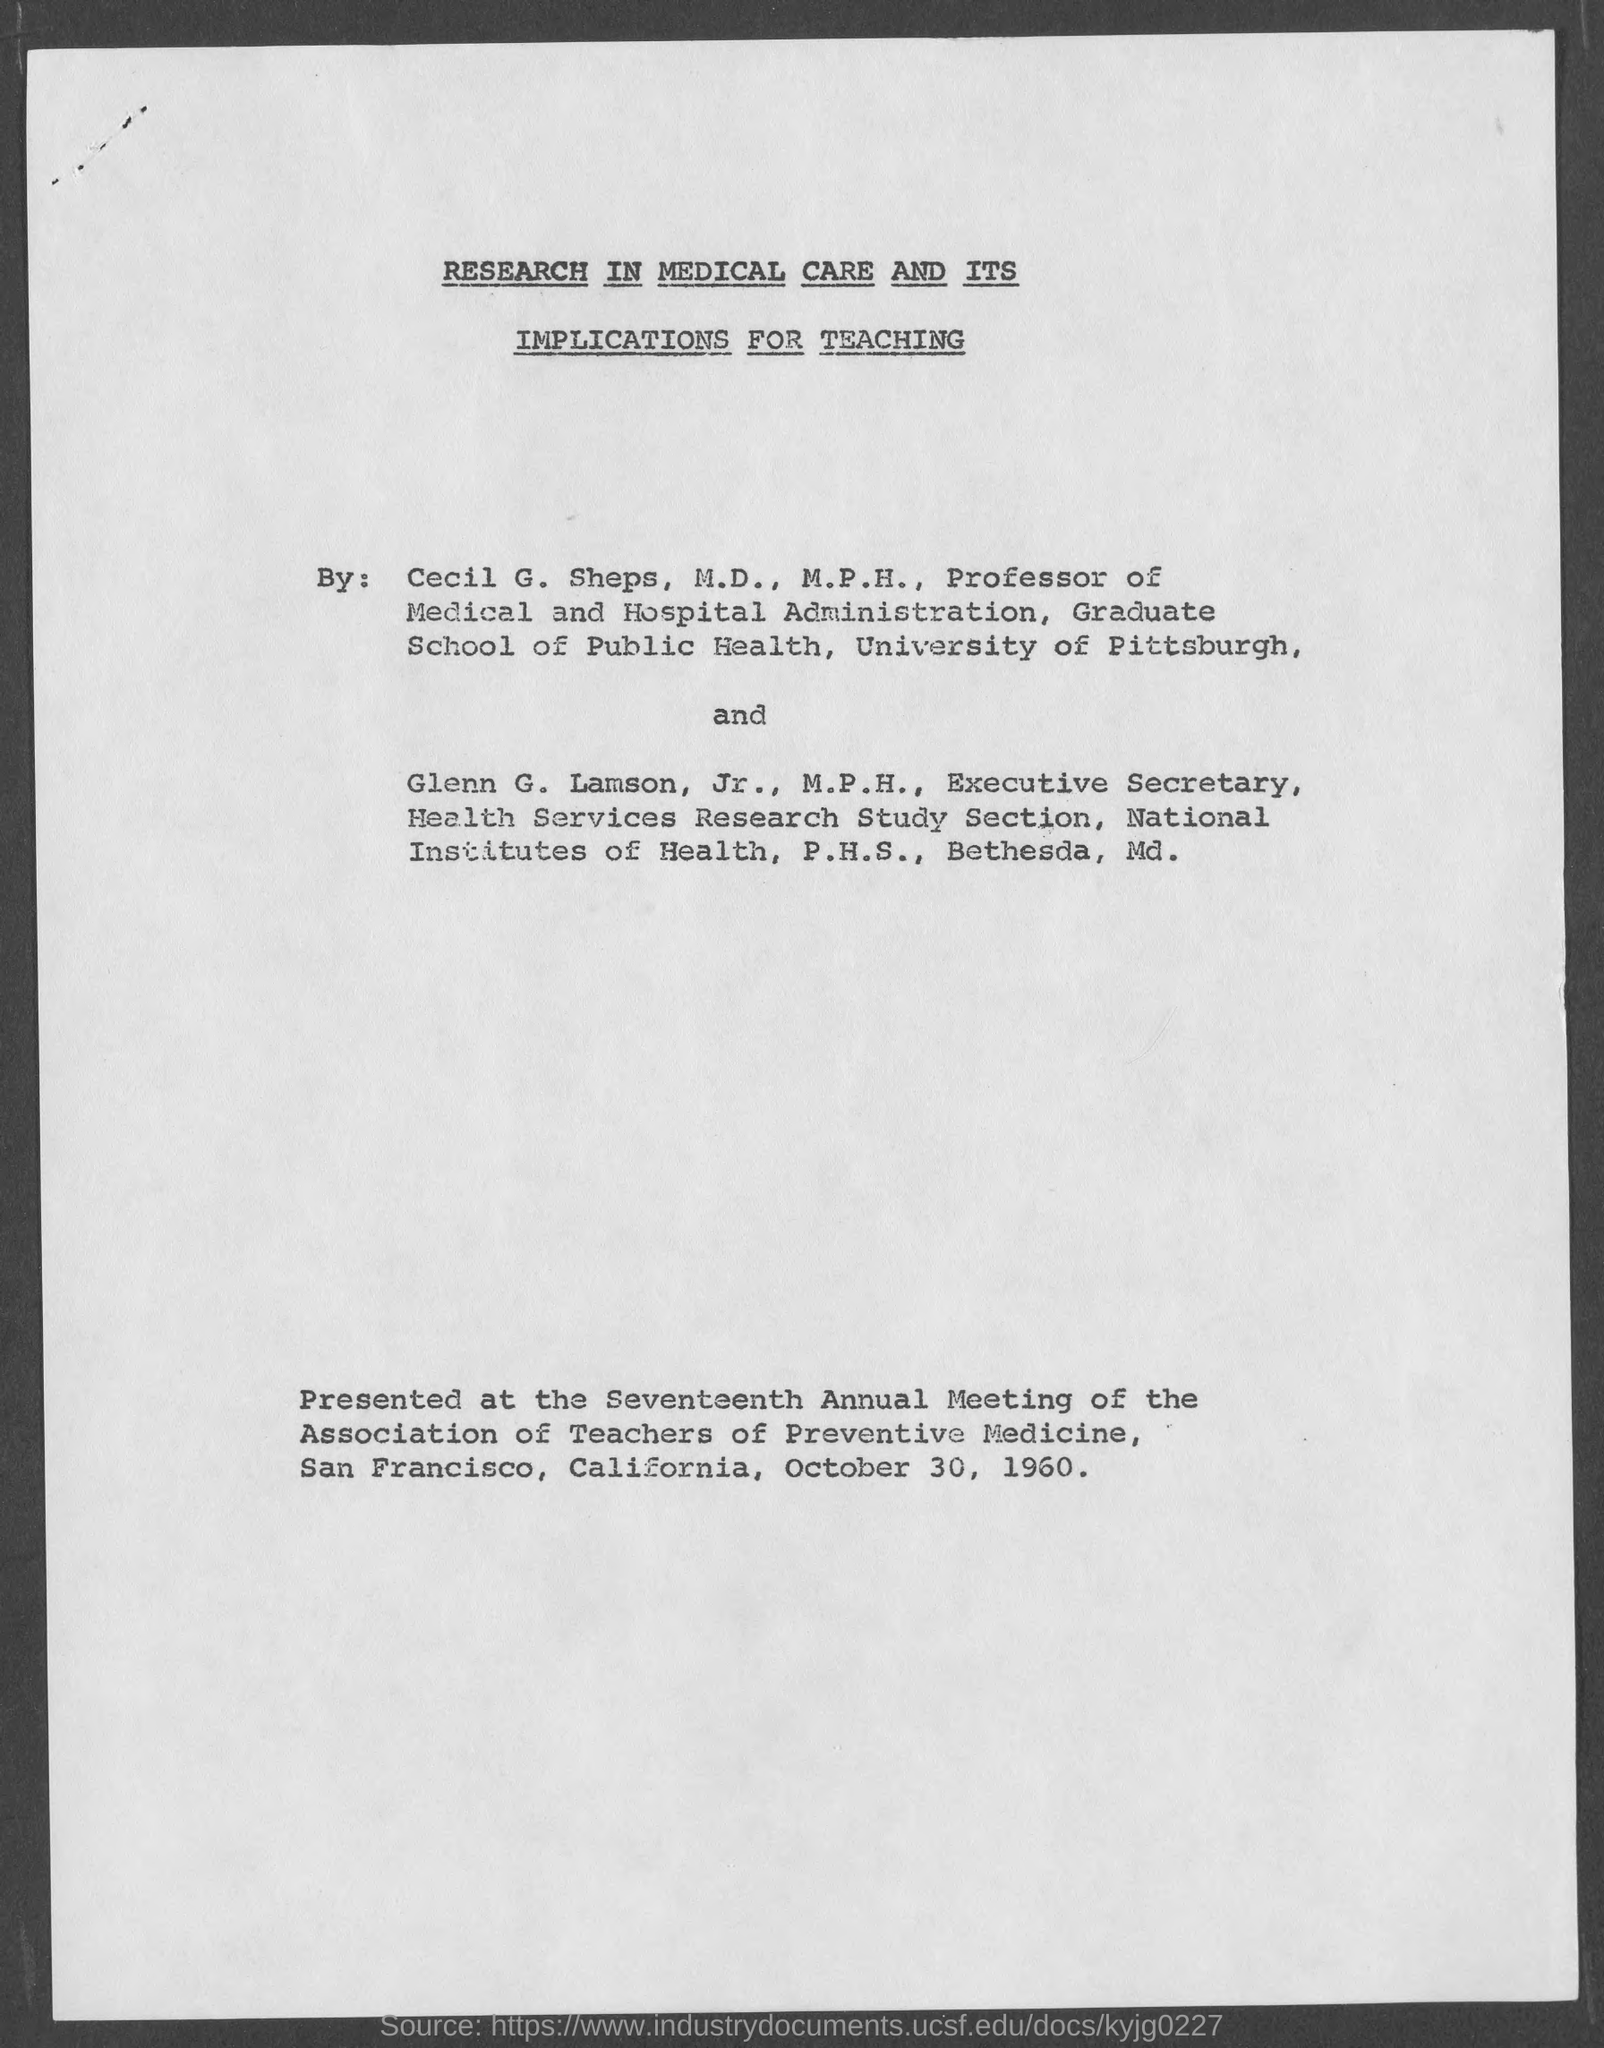Where & when was the Seventeenth Annual Meeting of the Association of Teachers of Preventive Medicine held?
Your answer should be compact. San Francisco, California, October 30, 1960. Who is the Executive Secretary, Health Services Research Study Section?
Provide a succinct answer. Glenn G. Lamson, Jr., M.P.H.,. Who is the Professor of Medical and Hospital Administration, Graduate School of Public Health?
Offer a very short reply. Cecil G. Sheps. Which paper was presented  at the Seventeenth Annual Meeting of the Association of Teachers of Preventive Medicine?
Your answer should be very brief. Research in medical care and its implications for teaching. 